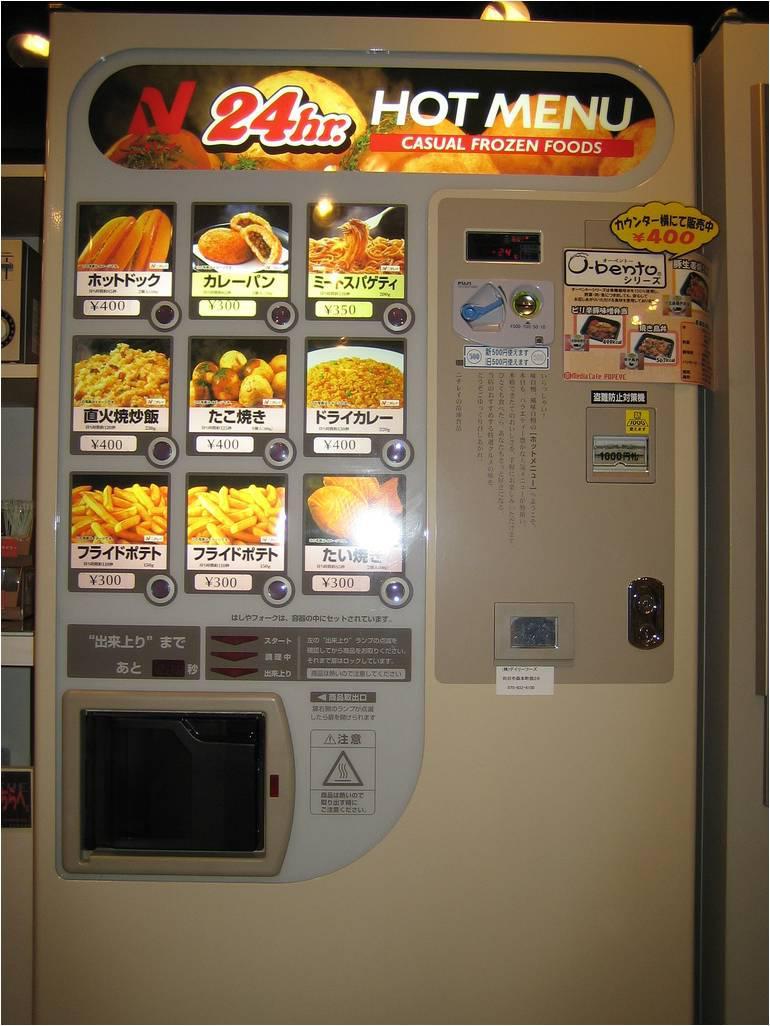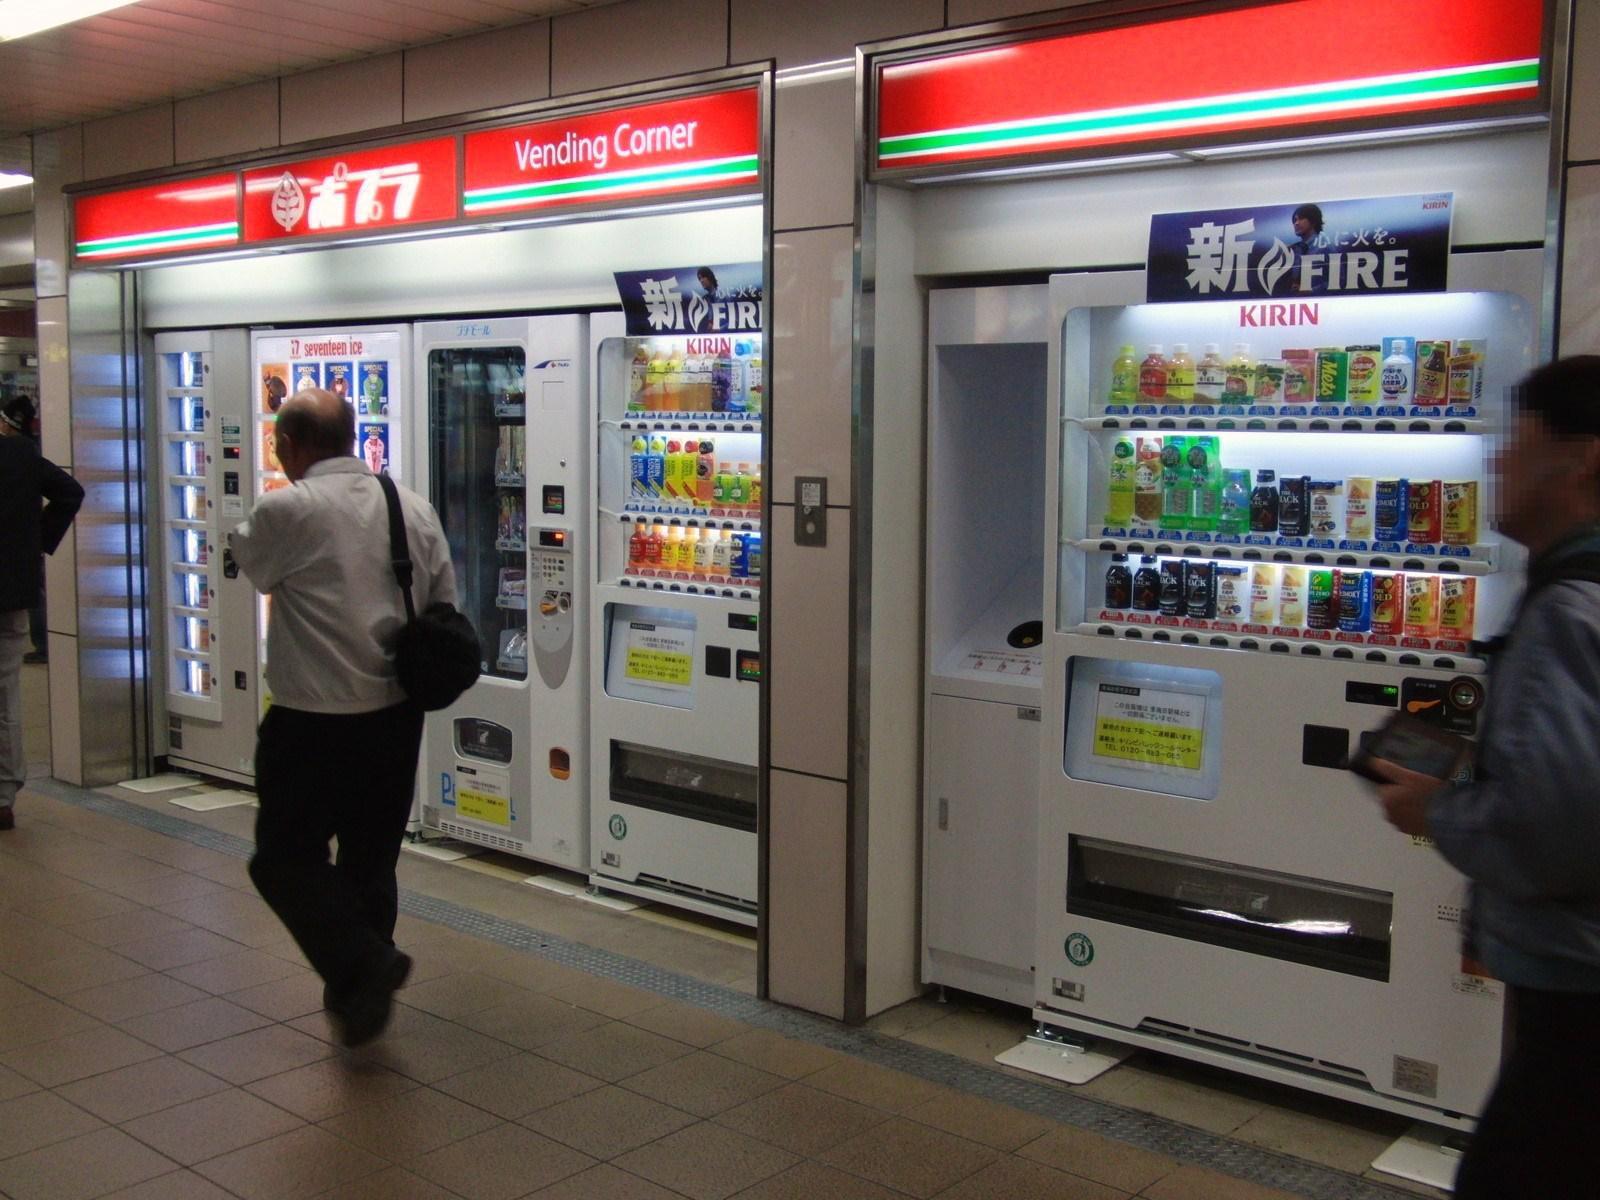The first image is the image on the left, the second image is the image on the right. For the images shown, is this caption "One image shows blue vending machines flanking two other machines in a row facing the camera head-on." true? Answer yes or no. No. The first image is the image on the left, the second image is the image on the right. Examine the images to the left and right. Is the description "Four machines are lined up in the image on the right." accurate? Answer yes or no. No. 